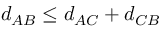Convert formula to latex. <formula><loc_0><loc_0><loc_500><loc_500>d _ { A B } \leq d _ { A C } + d _ { C B }</formula> 